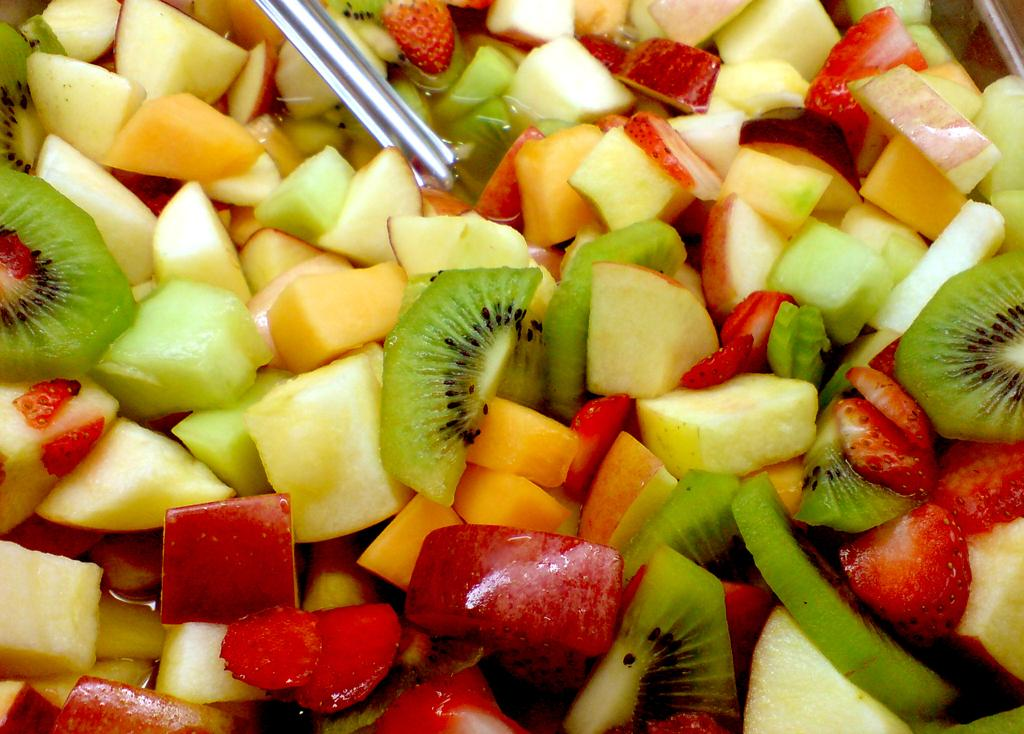What type of food can be seen in the image? There are chopped fruits in the image. What else is present in the image besides the chopped fruits? There is liquid and a spoon in the image. Can you see any connections between the chopped fruits and the seashore in the image? There is no seashore present in the image, so it is not possible to see any connections between the chopped fruits and the seashore. 